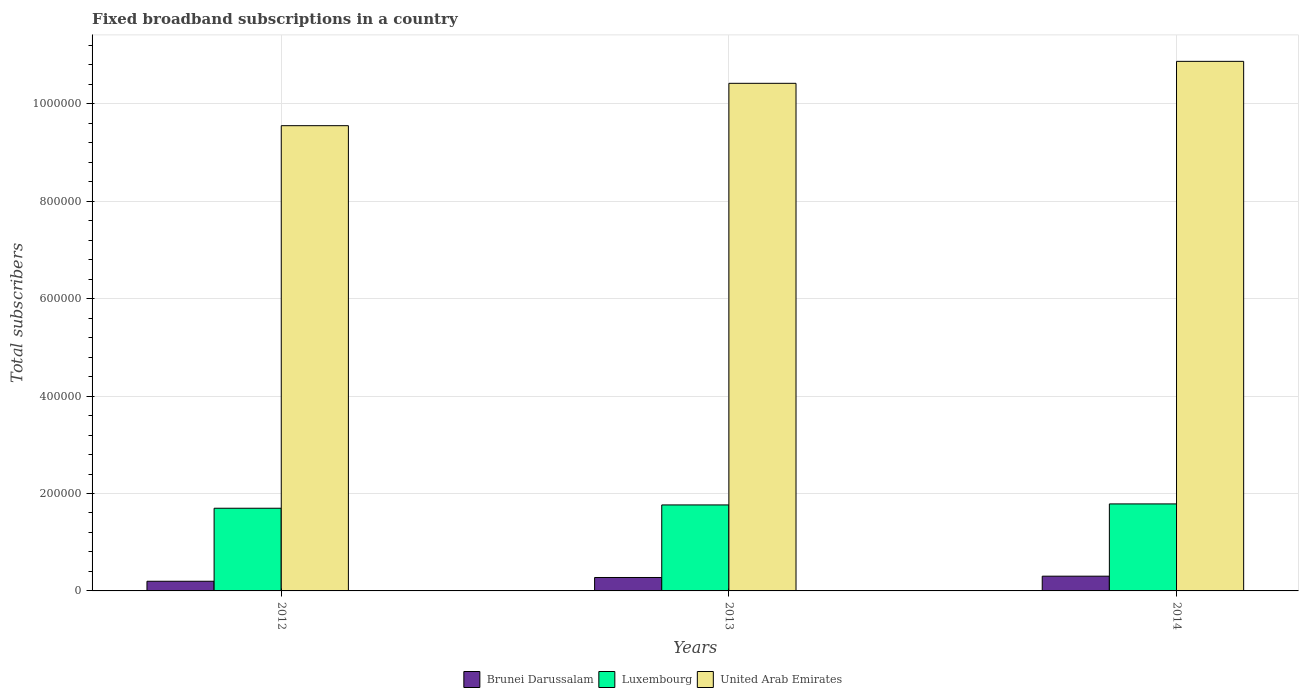How many different coloured bars are there?
Ensure brevity in your answer.  3. How many groups of bars are there?
Your answer should be very brief. 3. Are the number of bars on each tick of the X-axis equal?
Provide a short and direct response. Yes. How many bars are there on the 3rd tick from the left?
Your response must be concise. 3. In how many cases, is the number of bars for a given year not equal to the number of legend labels?
Make the answer very short. 0. What is the number of broadband subscriptions in United Arab Emirates in 2012?
Make the answer very short. 9.55e+05. Across all years, what is the maximum number of broadband subscriptions in United Arab Emirates?
Provide a short and direct response. 1.09e+06. Across all years, what is the minimum number of broadband subscriptions in United Arab Emirates?
Provide a succinct answer. 9.55e+05. In which year was the number of broadband subscriptions in United Arab Emirates maximum?
Provide a short and direct response. 2014. What is the total number of broadband subscriptions in United Arab Emirates in the graph?
Offer a terse response. 3.08e+06. What is the difference between the number of broadband subscriptions in Brunei Darussalam in 2012 and that in 2014?
Offer a very short reply. -1.04e+04. What is the difference between the number of broadband subscriptions in Brunei Darussalam in 2014 and the number of broadband subscriptions in United Arab Emirates in 2012?
Make the answer very short. -9.25e+05. What is the average number of broadband subscriptions in Brunei Darussalam per year?
Offer a very short reply. 2.59e+04. In the year 2012, what is the difference between the number of broadband subscriptions in Luxembourg and number of broadband subscriptions in Brunei Darussalam?
Keep it short and to the point. 1.50e+05. In how many years, is the number of broadband subscriptions in United Arab Emirates greater than 600000?
Give a very brief answer. 3. What is the ratio of the number of broadband subscriptions in United Arab Emirates in 2012 to that in 2014?
Offer a terse response. 0.88. What is the difference between the highest and the second highest number of broadband subscriptions in Brunei Darussalam?
Offer a very short reply. 2702. What is the difference between the highest and the lowest number of broadband subscriptions in United Arab Emirates?
Your response must be concise. 1.32e+05. What does the 1st bar from the left in 2013 represents?
Your answer should be compact. Brunei Darussalam. What does the 3rd bar from the right in 2014 represents?
Offer a very short reply. Brunei Darussalam. Is it the case that in every year, the sum of the number of broadband subscriptions in Luxembourg and number of broadband subscriptions in Brunei Darussalam is greater than the number of broadband subscriptions in United Arab Emirates?
Keep it short and to the point. No. How many years are there in the graph?
Offer a very short reply. 3. Does the graph contain grids?
Provide a succinct answer. Yes. Where does the legend appear in the graph?
Offer a terse response. Bottom center. What is the title of the graph?
Provide a short and direct response. Fixed broadband subscriptions in a country. What is the label or title of the Y-axis?
Keep it short and to the point. Total subscribers. What is the Total subscribers of Brunei Darussalam in 2012?
Your answer should be compact. 1.98e+04. What is the Total subscribers of Luxembourg in 2012?
Provide a short and direct response. 1.70e+05. What is the Total subscribers of United Arab Emirates in 2012?
Make the answer very short. 9.55e+05. What is the Total subscribers of Brunei Darussalam in 2013?
Provide a short and direct response. 2.76e+04. What is the Total subscribers of Luxembourg in 2013?
Offer a very short reply. 1.76e+05. What is the Total subscribers of United Arab Emirates in 2013?
Your response must be concise. 1.04e+06. What is the Total subscribers in Brunei Darussalam in 2014?
Make the answer very short. 3.03e+04. What is the Total subscribers in Luxembourg in 2014?
Make the answer very short. 1.79e+05. What is the Total subscribers of United Arab Emirates in 2014?
Give a very brief answer. 1.09e+06. Across all years, what is the maximum Total subscribers of Brunei Darussalam?
Ensure brevity in your answer.  3.03e+04. Across all years, what is the maximum Total subscribers of Luxembourg?
Your response must be concise. 1.79e+05. Across all years, what is the maximum Total subscribers of United Arab Emirates?
Your answer should be compact. 1.09e+06. Across all years, what is the minimum Total subscribers in Brunei Darussalam?
Keep it short and to the point. 1.98e+04. Across all years, what is the minimum Total subscribers of Luxembourg?
Your answer should be compact. 1.70e+05. Across all years, what is the minimum Total subscribers in United Arab Emirates?
Offer a very short reply. 9.55e+05. What is the total Total subscribers of Brunei Darussalam in the graph?
Offer a terse response. 7.77e+04. What is the total Total subscribers in Luxembourg in the graph?
Offer a very short reply. 5.25e+05. What is the total Total subscribers of United Arab Emirates in the graph?
Make the answer very short. 3.08e+06. What is the difference between the Total subscribers in Brunei Darussalam in 2012 and that in 2013?
Your answer should be compact. -7708. What is the difference between the Total subscribers of Luxembourg in 2012 and that in 2013?
Ensure brevity in your answer.  -6800. What is the difference between the Total subscribers in United Arab Emirates in 2012 and that in 2013?
Make the answer very short. -8.69e+04. What is the difference between the Total subscribers of Brunei Darussalam in 2012 and that in 2014?
Provide a succinct answer. -1.04e+04. What is the difference between the Total subscribers of Luxembourg in 2012 and that in 2014?
Give a very brief answer. -8900. What is the difference between the Total subscribers of United Arab Emirates in 2012 and that in 2014?
Give a very brief answer. -1.32e+05. What is the difference between the Total subscribers of Brunei Darussalam in 2013 and that in 2014?
Provide a succinct answer. -2702. What is the difference between the Total subscribers of Luxembourg in 2013 and that in 2014?
Your response must be concise. -2100. What is the difference between the Total subscribers in United Arab Emirates in 2013 and that in 2014?
Your answer should be compact. -4.51e+04. What is the difference between the Total subscribers of Brunei Darussalam in 2012 and the Total subscribers of Luxembourg in 2013?
Offer a terse response. -1.57e+05. What is the difference between the Total subscribers in Brunei Darussalam in 2012 and the Total subscribers in United Arab Emirates in 2013?
Keep it short and to the point. -1.02e+06. What is the difference between the Total subscribers in Luxembourg in 2012 and the Total subscribers in United Arab Emirates in 2013?
Your answer should be very brief. -8.72e+05. What is the difference between the Total subscribers in Brunei Darussalam in 2012 and the Total subscribers in Luxembourg in 2014?
Offer a terse response. -1.59e+05. What is the difference between the Total subscribers in Brunei Darussalam in 2012 and the Total subscribers in United Arab Emirates in 2014?
Provide a short and direct response. -1.07e+06. What is the difference between the Total subscribers of Luxembourg in 2012 and the Total subscribers of United Arab Emirates in 2014?
Your answer should be very brief. -9.17e+05. What is the difference between the Total subscribers of Brunei Darussalam in 2013 and the Total subscribers of Luxembourg in 2014?
Keep it short and to the point. -1.51e+05. What is the difference between the Total subscribers of Brunei Darussalam in 2013 and the Total subscribers of United Arab Emirates in 2014?
Make the answer very short. -1.06e+06. What is the difference between the Total subscribers of Luxembourg in 2013 and the Total subscribers of United Arab Emirates in 2014?
Make the answer very short. -9.11e+05. What is the average Total subscribers in Brunei Darussalam per year?
Keep it short and to the point. 2.59e+04. What is the average Total subscribers of Luxembourg per year?
Ensure brevity in your answer.  1.75e+05. What is the average Total subscribers in United Arab Emirates per year?
Ensure brevity in your answer.  1.03e+06. In the year 2012, what is the difference between the Total subscribers in Brunei Darussalam and Total subscribers in Luxembourg?
Offer a very short reply. -1.50e+05. In the year 2012, what is the difference between the Total subscribers in Brunei Darussalam and Total subscribers in United Arab Emirates?
Ensure brevity in your answer.  -9.35e+05. In the year 2012, what is the difference between the Total subscribers of Luxembourg and Total subscribers of United Arab Emirates?
Ensure brevity in your answer.  -7.85e+05. In the year 2013, what is the difference between the Total subscribers in Brunei Darussalam and Total subscribers in Luxembourg?
Ensure brevity in your answer.  -1.49e+05. In the year 2013, what is the difference between the Total subscribers of Brunei Darussalam and Total subscribers of United Arab Emirates?
Ensure brevity in your answer.  -1.01e+06. In the year 2013, what is the difference between the Total subscribers of Luxembourg and Total subscribers of United Arab Emirates?
Your response must be concise. -8.65e+05. In the year 2014, what is the difference between the Total subscribers of Brunei Darussalam and Total subscribers of Luxembourg?
Your answer should be compact. -1.48e+05. In the year 2014, what is the difference between the Total subscribers of Brunei Darussalam and Total subscribers of United Arab Emirates?
Give a very brief answer. -1.06e+06. In the year 2014, what is the difference between the Total subscribers in Luxembourg and Total subscribers in United Arab Emirates?
Offer a terse response. -9.08e+05. What is the ratio of the Total subscribers of Brunei Darussalam in 2012 to that in 2013?
Make the answer very short. 0.72. What is the ratio of the Total subscribers in Luxembourg in 2012 to that in 2013?
Keep it short and to the point. 0.96. What is the ratio of the Total subscribers in United Arab Emirates in 2012 to that in 2013?
Provide a short and direct response. 0.92. What is the ratio of the Total subscribers of Brunei Darussalam in 2012 to that in 2014?
Provide a short and direct response. 0.66. What is the ratio of the Total subscribers of Luxembourg in 2012 to that in 2014?
Your answer should be very brief. 0.95. What is the ratio of the Total subscribers in United Arab Emirates in 2012 to that in 2014?
Provide a short and direct response. 0.88. What is the ratio of the Total subscribers of Brunei Darussalam in 2013 to that in 2014?
Provide a short and direct response. 0.91. What is the ratio of the Total subscribers in Luxembourg in 2013 to that in 2014?
Give a very brief answer. 0.99. What is the ratio of the Total subscribers in United Arab Emirates in 2013 to that in 2014?
Your response must be concise. 0.96. What is the difference between the highest and the second highest Total subscribers of Brunei Darussalam?
Your response must be concise. 2702. What is the difference between the highest and the second highest Total subscribers of Luxembourg?
Provide a succinct answer. 2100. What is the difference between the highest and the second highest Total subscribers in United Arab Emirates?
Provide a succinct answer. 4.51e+04. What is the difference between the highest and the lowest Total subscribers of Brunei Darussalam?
Make the answer very short. 1.04e+04. What is the difference between the highest and the lowest Total subscribers in Luxembourg?
Your answer should be very brief. 8900. What is the difference between the highest and the lowest Total subscribers in United Arab Emirates?
Offer a very short reply. 1.32e+05. 